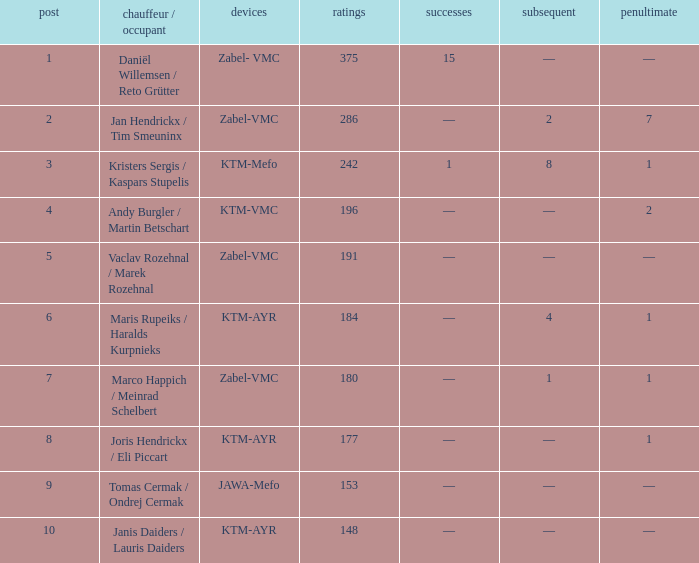Who was the pilot/occupant when the spot was below 8, the third was 1, and there was 1 success? Kristers Sergis / Kaspars Stupelis. Could you parse the entire table as a dict? {'header': ['post', 'chauffeur / occupant', 'devices', 'ratings', 'successes', 'subsequent', 'penultimate'], 'rows': [['1', 'Daniël Willemsen / Reto Grütter', 'Zabel- VMC', '375', '15', '—', '—'], ['2', 'Jan Hendrickx / Tim Smeuninx', 'Zabel-VMC', '286', '—', '2', '7'], ['3', 'Kristers Sergis / Kaspars Stupelis', 'KTM-Mefo', '242', '1', '8', '1'], ['4', 'Andy Burgler / Martin Betschart', 'KTM-VMC', '196', '—', '—', '2'], ['5', 'Vaclav Rozehnal / Marek Rozehnal', 'Zabel-VMC', '191', '—', '—', '—'], ['6', 'Maris Rupeiks / Haralds Kurpnieks', 'KTM-AYR', '184', '—', '4', '1'], ['7', 'Marco Happich / Meinrad Schelbert', 'Zabel-VMC', '180', '—', '1', '1'], ['8', 'Joris Hendrickx / Eli Piccart', 'KTM-AYR', '177', '—', '—', '1'], ['9', 'Tomas Cermak / Ondrej Cermak', 'JAWA-Mefo', '153', '—', '—', '—'], ['10', 'Janis Daiders / Lauris Daiders', 'KTM-AYR', '148', '—', '—', '—']]} 